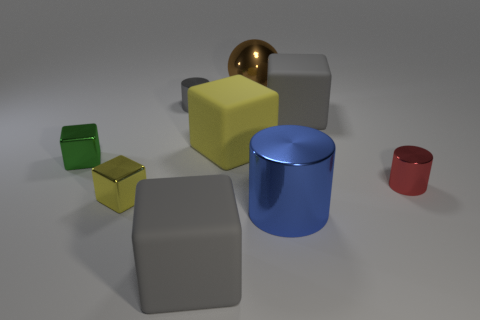Subtract 1 cubes. How many cubes are left? 4 Subtract all green cubes. How many cubes are left? 4 Subtract all small yellow shiny cubes. How many cubes are left? 4 Subtract all red blocks. Subtract all blue spheres. How many blocks are left? 5 Subtract all blocks. How many objects are left? 4 Add 7 small blocks. How many small blocks are left? 9 Add 7 big yellow matte cylinders. How many big yellow matte cylinders exist? 7 Subtract 0 blue balls. How many objects are left? 9 Subtract all tiny green shiny cylinders. Subtract all large yellow blocks. How many objects are left? 8 